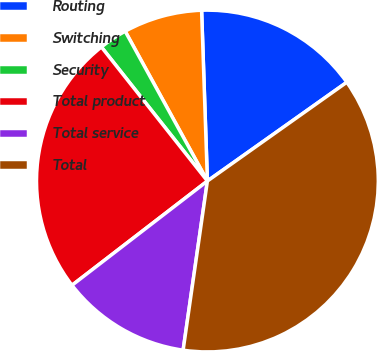<chart> <loc_0><loc_0><loc_500><loc_500><pie_chart><fcel>Routing<fcel>Switching<fcel>Security<fcel>Total product<fcel>Total service<fcel>Total<nl><fcel>15.73%<fcel>7.45%<fcel>2.66%<fcel>24.79%<fcel>12.29%<fcel>37.08%<nl></chart> 